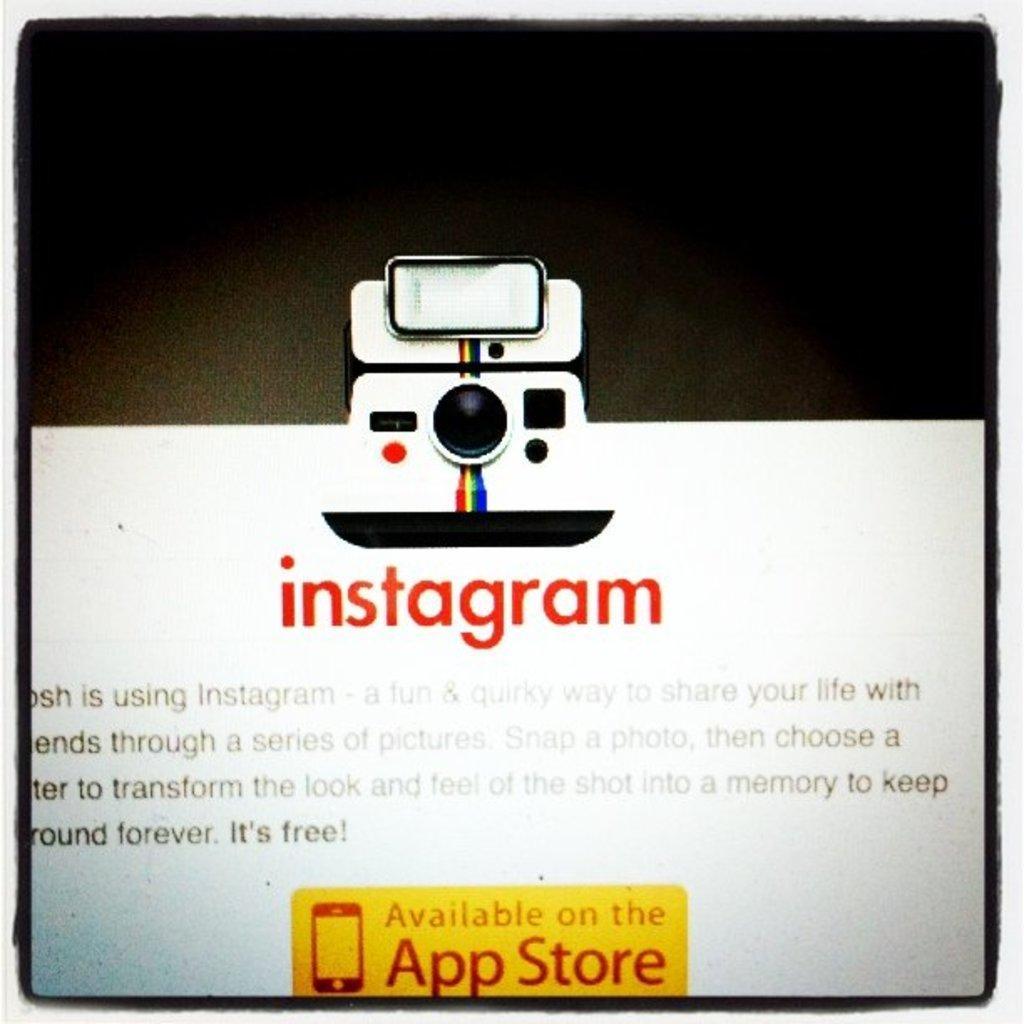How would you summarize this image in a sentence or two? In this an image of the poster where we can see some text and object. 